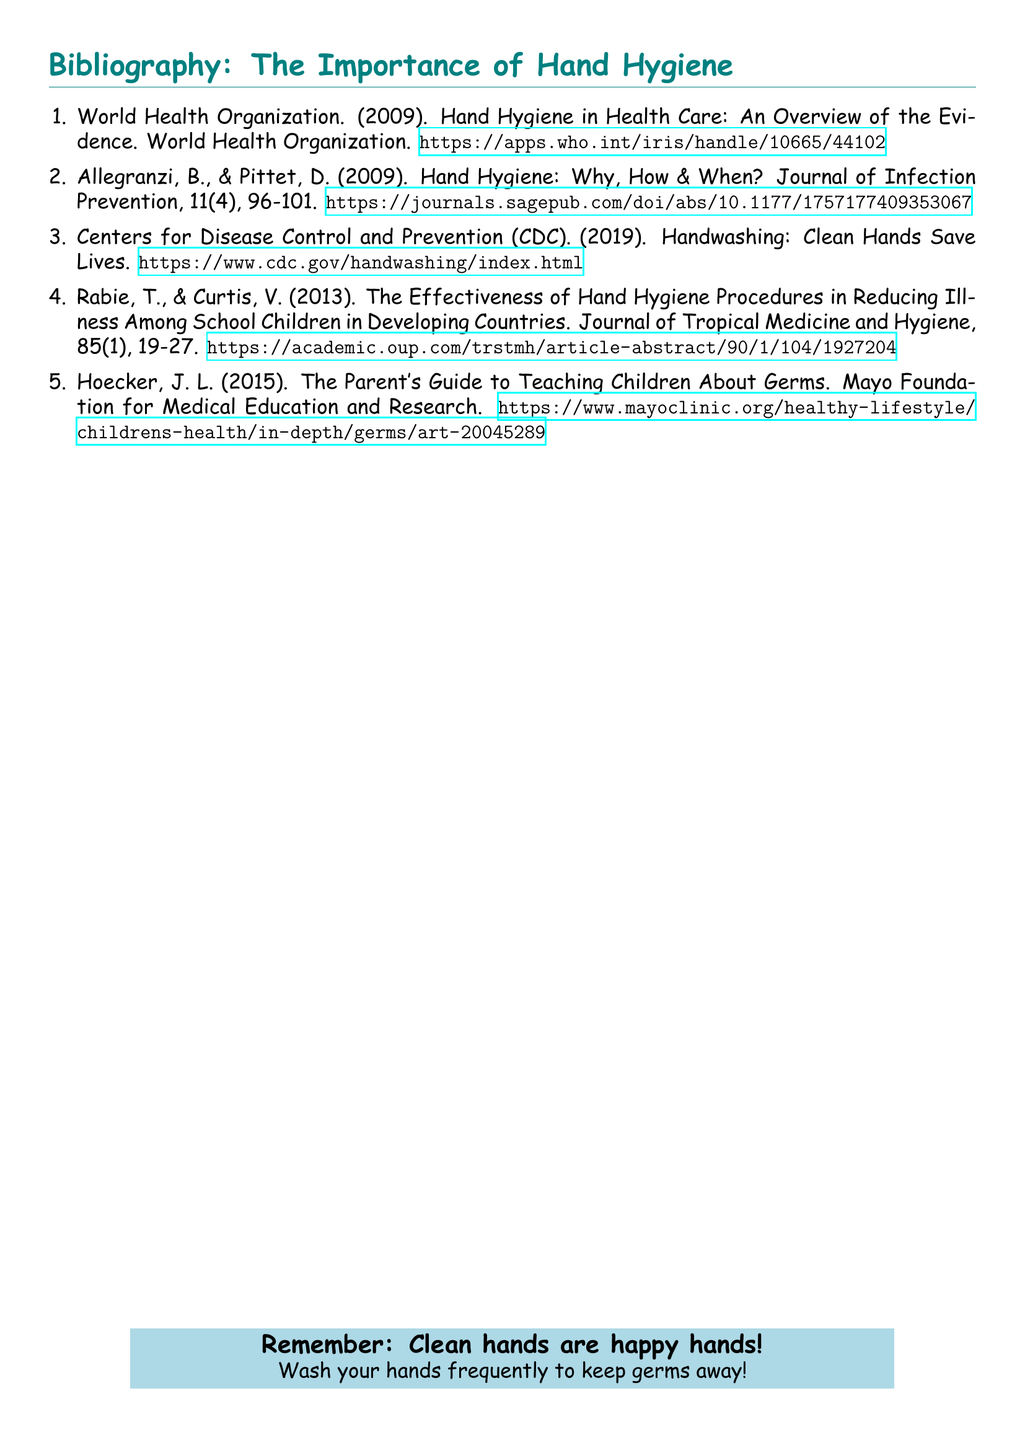What is the title of the first item in the bibliography? The title of the first item is a standard bibliographic entry which typically includes the title of the work cited.
Answer: Hand Hygiene in Health Care: An Overview of the Evidence Who are the authors of the second item listed? The authors of the second item are cited in the bibliographic entry, showing their contributions to the topic.
Answer: Allegranzi, B., & Pittet, D What year was the CDC’s handwashing resource published? The year of publication can be found in the bibliographic information for the CDC resource.
Answer: 2019 What type of source is Hoecker's entry? This question pertains to knowing what category the bibliographic entry represents in relation to health guidance for parents.
Answer: Guide Which journal published the article by Rabie and Curtis? The journal title is typically included in bibliographic entries and helps identify where the research was published.
Answer: Journal of Tropical Medicine and Hygiene What is the main theme of this bibliography? The overall theme is typically derived from the titles and subjects of the listed works.
Answer: Hand hygiene and illness prevention What is the color of the background in the bibliographic document? The color choice serves a design purpose and can manifest the document's thematic focus on cleanliness.
Answer: White What is emphasized in the final note of the document? The final note contains a reminder phrase that conveys the primary message of the document.
Answer: Clean hands are happy hands! 